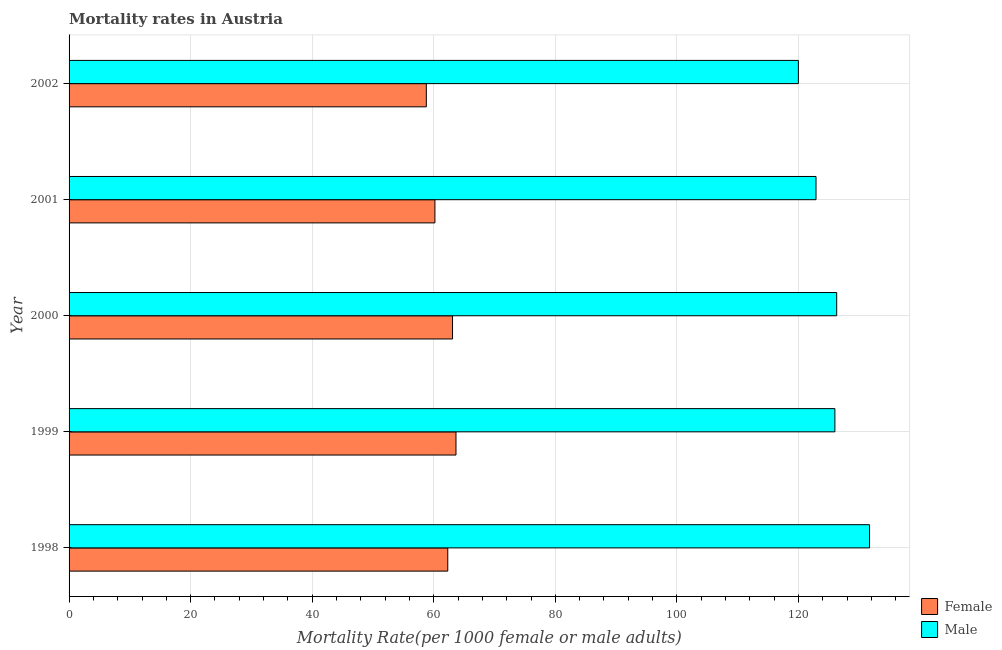How many different coloured bars are there?
Provide a succinct answer. 2. How many bars are there on the 2nd tick from the top?
Your answer should be compact. 2. What is the label of the 4th group of bars from the top?
Your answer should be very brief. 1999. What is the female mortality rate in 1998?
Your answer should be compact. 62.3. Across all years, what is the maximum male mortality rate?
Offer a very short reply. 131.7. Across all years, what is the minimum male mortality rate?
Offer a very short reply. 119.99. What is the total female mortality rate in the graph?
Your answer should be very brief. 308.01. What is the difference between the female mortality rate in 1998 and that in 1999?
Give a very brief answer. -1.35. What is the difference between the female mortality rate in 1998 and the male mortality rate in 2000?
Give a very brief answer. -63.99. What is the average male mortality rate per year?
Give a very brief answer. 125.37. In the year 1998, what is the difference between the male mortality rate and female mortality rate?
Your answer should be very brief. 69.39. What is the ratio of the male mortality rate in 1998 to that in 1999?
Your answer should be very brief. 1.04. Is the male mortality rate in 1999 less than that in 2000?
Your response must be concise. Yes. Is the difference between the male mortality rate in 1998 and 1999 greater than the difference between the female mortality rate in 1998 and 1999?
Offer a very short reply. Yes. What is the difference between the highest and the second highest female mortality rate?
Provide a short and direct response. 0.57. What is the difference between the highest and the lowest female mortality rate?
Offer a terse response. 4.88. In how many years, is the male mortality rate greater than the average male mortality rate taken over all years?
Give a very brief answer. 3. What does the 2nd bar from the top in 1999 represents?
Your answer should be compact. Female. What does the 2nd bar from the bottom in 2001 represents?
Offer a terse response. Male. How many bars are there?
Your response must be concise. 10. How many years are there in the graph?
Offer a terse response. 5. What is the difference between two consecutive major ticks on the X-axis?
Your response must be concise. 20. How many legend labels are there?
Your response must be concise. 2. What is the title of the graph?
Keep it short and to the point. Mortality rates in Austria. Does "Pregnant women" appear as one of the legend labels in the graph?
Offer a terse response. No. What is the label or title of the X-axis?
Offer a terse response. Mortality Rate(per 1000 female or male adults). What is the label or title of the Y-axis?
Keep it short and to the point. Year. What is the Mortality Rate(per 1000 female or male adults) in Female in 1998?
Your response must be concise. 62.3. What is the Mortality Rate(per 1000 female or male adults) of Male in 1998?
Keep it short and to the point. 131.7. What is the Mortality Rate(per 1000 female or male adults) of Female in 1999?
Ensure brevity in your answer.  63.66. What is the Mortality Rate(per 1000 female or male adults) in Male in 1999?
Provide a short and direct response. 125.99. What is the Mortality Rate(per 1000 female or male adults) of Female in 2000?
Give a very brief answer. 63.09. What is the Mortality Rate(per 1000 female or male adults) of Male in 2000?
Ensure brevity in your answer.  126.29. What is the Mortality Rate(per 1000 female or male adults) in Female in 2001?
Offer a very short reply. 60.19. What is the Mortality Rate(per 1000 female or male adults) of Male in 2001?
Make the answer very short. 122.89. What is the Mortality Rate(per 1000 female or male adults) of Female in 2002?
Give a very brief answer. 58.78. What is the Mortality Rate(per 1000 female or male adults) in Male in 2002?
Provide a short and direct response. 119.99. Across all years, what is the maximum Mortality Rate(per 1000 female or male adults) of Female?
Provide a succinct answer. 63.66. Across all years, what is the maximum Mortality Rate(per 1000 female or male adults) of Male?
Offer a very short reply. 131.7. Across all years, what is the minimum Mortality Rate(per 1000 female or male adults) of Female?
Your answer should be very brief. 58.78. Across all years, what is the minimum Mortality Rate(per 1000 female or male adults) in Male?
Make the answer very short. 119.99. What is the total Mortality Rate(per 1000 female or male adults) of Female in the graph?
Make the answer very short. 308.01. What is the total Mortality Rate(per 1000 female or male adults) of Male in the graph?
Your response must be concise. 626.85. What is the difference between the Mortality Rate(per 1000 female or male adults) of Female in 1998 and that in 1999?
Your answer should be compact. -1.35. What is the difference between the Mortality Rate(per 1000 female or male adults) in Male in 1998 and that in 1999?
Provide a short and direct response. 5.71. What is the difference between the Mortality Rate(per 1000 female or male adults) in Female in 1998 and that in 2000?
Make the answer very short. -0.78. What is the difference between the Mortality Rate(per 1000 female or male adults) in Male in 1998 and that in 2000?
Make the answer very short. 5.41. What is the difference between the Mortality Rate(per 1000 female or male adults) of Female in 1998 and that in 2001?
Keep it short and to the point. 2.11. What is the difference between the Mortality Rate(per 1000 female or male adults) of Male in 1998 and that in 2001?
Provide a succinct answer. 8.81. What is the difference between the Mortality Rate(per 1000 female or male adults) in Female in 1998 and that in 2002?
Provide a succinct answer. 3.52. What is the difference between the Mortality Rate(per 1000 female or male adults) in Male in 1998 and that in 2002?
Provide a succinct answer. 11.71. What is the difference between the Mortality Rate(per 1000 female or male adults) in Female in 1999 and that in 2000?
Provide a short and direct response. 0.57. What is the difference between the Mortality Rate(per 1000 female or male adults) of Male in 1999 and that in 2000?
Your response must be concise. -0.3. What is the difference between the Mortality Rate(per 1000 female or male adults) in Female in 1999 and that in 2001?
Keep it short and to the point. 3.47. What is the difference between the Mortality Rate(per 1000 female or male adults) in Male in 1999 and that in 2001?
Your answer should be very brief. 3.1. What is the difference between the Mortality Rate(per 1000 female or male adults) in Female in 1999 and that in 2002?
Your answer should be very brief. 4.88. What is the difference between the Mortality Rate(per 1000 female or male adults) of Male in 1999 and that in 2002?
Your response must be concise. 6. What is the difference between the Mortality Rate(per 1000 female or male adults) of Female in 2000 and that in 2001?
Offer a terse response. 2.9. What is the difference between the Mortality Rate(per 1000 female or male adults) of Male in 2000 and that in 2001?
Give a very brief answer. 3.4. What is the difference between the Mortality Rate(per 1000 female or male adults) in Female in 2000 and that in 2002?
Ensure brevity in your answer.  4.31. What is the difference between the Mortality Rate(per 1000 female or male adults) of Male in 2000 and that in 2002?
Your answer should be compact. 6.3. What is the difference between the Mortality Rate(per 1000 female or male adults) of Female in 2001 and that in 2002?
Offer a terse response. 1.41. What is the difference between the Mortality Rate(per 1000 female or male adults) of Male in 2001 and that in 2002?
Your answer should be compact. 2.9. What is the difference between the Mortality Rate(per 1000 female or male adults) in Female in 1998 and the Mortality Rate(per 1000 female or male adults) in Male in 1999?
Make the answer very short. -63.69. What is the difference between the Mortality Rate(per 1000 female or male adults) in Female in 1998 and the Mortality Rate(per 1000 female or male adults) in Male in 2000?
Provide a succinct answer. -63.99. What is the difference between the Mortality Rate(per 1000 female or male adults) of Female in 1998 and the Mortality Rate(per 1000 female or male adults) of Male in 2001?
Provide a succinct answer. -60.59. What is the difference between the Mortality Rate(per 1000 female or male adults) in Female in 1998 and the Mortality Rate(per 1000 female or male adults) in Male in 2002?
Offer a terse response. -57.69. What is the difference between the Mortality Rate(per 1000 female or male adults) in Female in 1999 and the Mortality Rate(per 1000 female or male adults) in Male in 2000?
Provide a short and direct response. -62.63. What is the difference between the Mortality Rate(per 1000 female or male adults) in Female in 1999 and the Mortality Rate(per 1000 female or male adults) in Male in 2001?
Provide a short and direct response. -59.23. What is the difference between the Mortality Rate(per 1000 female or male adults) in Female in 1999 and the Mortality Rate(per 1000 female or male adults) in Male in 2002?
Your response must be concise. -56.33. What is the difference between the Mortality Rate(per 1000 female or male adults) of Female in 2000 and the Mortality Rate(per 1000 female or male adults) of Male in 2001?
Offer a terse response. -59.8. What is the difference between the Mortality Rate(per 1000 female or male adults) in Female in 2000 and the Mortality Rate(per 1000 female or male adults) in Male in 2002?
Your response must be concise. -56.9. What is the difference between the Mortality Rate(per 1000 female or male adults) of Female in 2001 and the Mortality Rate(per 1000 female or male adults) of Male in 2002?
Offer a terse response. -59.8. What is the average Mortality Rate(per 1000 female or male adults) of Female per year?
Provide a short and direct response. 61.6. What is the average Mortality Rate(per 1000 female or male adults) in Male per year?
Provide a short and direct response. 125.37. In the year 1998, what is the difference between the Mortality Rate(per 1000 female or male adults) of Female and Mortality Rate(per 1000 female or male adults) of Male?
Ensure brevity in your answer.  -69.39. In the year 1999, what is the difference between the Mortality Rate(per 1000 female or male adults) of Female and Mortality Rate(per 1000 female or male adults) of Male?
Your answer should be compact. -62.34. In the year 2000, what is the difference between the Mortality Rate(per 1000 female or male adults) of Female and Mortality Rate(per 1000 female or male adults) of Male?
Offer a terse response. -63.2. In the year 2001, what is the difference between the Mortality Rate(per 1000 female or male adults) in Female and Mortality Rate(per 1000 female or male adults) in Male?
Offer a very short reply. -62.7. In the year 2002, what is the difference between the Mortality Rate(per 1000 female or male adults) of Female and Mortality Rate(per 1000 female or male adults) of Male?
Ensure brevity in your answer.  -61.21. What is the ratio of the Mortality Rate(per 1000 female or male adults) in Female in 1998 to that in 1999?
Your response must be concise. 0.98. What is the ratio of the Mortality Rate(per 1000 female or male adults) of Male in 1998 to that in 1999?
Provide a succinct answer. 1.05. What is the ratio of the Mortality Rate(per 1000 female or male adults) in Female in 1998 to that in 2000?
Offer a very short reply. 0.99. What is the ratio of the Mortality Rate(per 1000 female or male adults) in Male in 1998 to that in 2000?
Offer a very short reply. 1.04. What is the ratio of the Mortality Rate(per 1000 female or male adults) of Female in 1998 to that in 2001?
Provide a succinct answer. 1.04. What is the ratio of the Mortality Rate(per 1000 female or male adults) of Male in 1998 to that in 2001?
Provide a short and direct response. 1.07. What is the ratio of the Mortality Rate(per 1000 female or male adults) in Female in 1998 to that in 2002?
Your response must be concise. 1.06. What is the ratio of the Mortality Rate(per 1000 female or male adults) in Male in 1998 to that in 2002?
Keep it short and to the point. 1.1. What is the ratio of the Mortality Rate(per 1000 female or male adults) in Female in 1999 to that in 2000?
Offer a very short reply. 1.01. What is the ratio of the Mortality Rate(per 1000 female or male adults) in Male in 1999 to that in 2000?
Provide a succinct answer. 1. What is the ratio of the Mortality Rate(per 1000 female or male adults) in Female in 1999 to that in 2001?
Keep it short and to the point. 1.06. What is the ratio of the Mortality Rate(per 1000 female or male adults) of Male in 1999 to that in 2001?
Give a very brief answer. 1.03. What is the ratio of the Mortality Rate(per 1000 female or male adults) of Female in 1999 to that in 2002?
Keep it short and to the point. 1.08. What is the ratio of the Mortality Rate(per 1000 female or male adults) in Male in 1999 to that in 2002?
Offer a very short reply. 1.05. What is the ratio of the Mortality Rate(per 1000 female or male adults) of Female in 2000 to that in 2001?
Ensure brevity in your answer.  1.05. What is the ratio of the Mortality Rate(per 1000 female or male adults) in Male in 2000 to that in 2001?
Your response must be concise. 1.03. What is the ratio of the Mortality Rate(per 1000 female or male adults) in Female in 2000 to that in 2002?
Give a very brief answer. 1.07. What is the ratio of the Mortality Rate(per 1000 female or male adults) in Male in 2000 to that in 2002?
Your answer should be compact. 1.05. What is the ratio of the Mortality Rate(per 1000 female or male adults) of Male in 2001 to that in 2002?
Ensure brevity in your answer.  1.02. What is the difference between the highest and the second highest Mortality Rate(per 1000 female or male adults) of Female?
Your answer should be compact. 0.57. What is the difference between the highest and the second highest Mortality Rate(per 1000 female or male adults) of Male?
Offer a terse response. 5.41. What is the difference between the highest and the lowest Mortality Rate(per 1000 female or male adults) in Female?
Provide a short and direct response. 4.88. What is the difference between the highest and the lowest Mortality Rate(per 1000 female or male adults) of Male?
Make the answer very short. 11.71. 